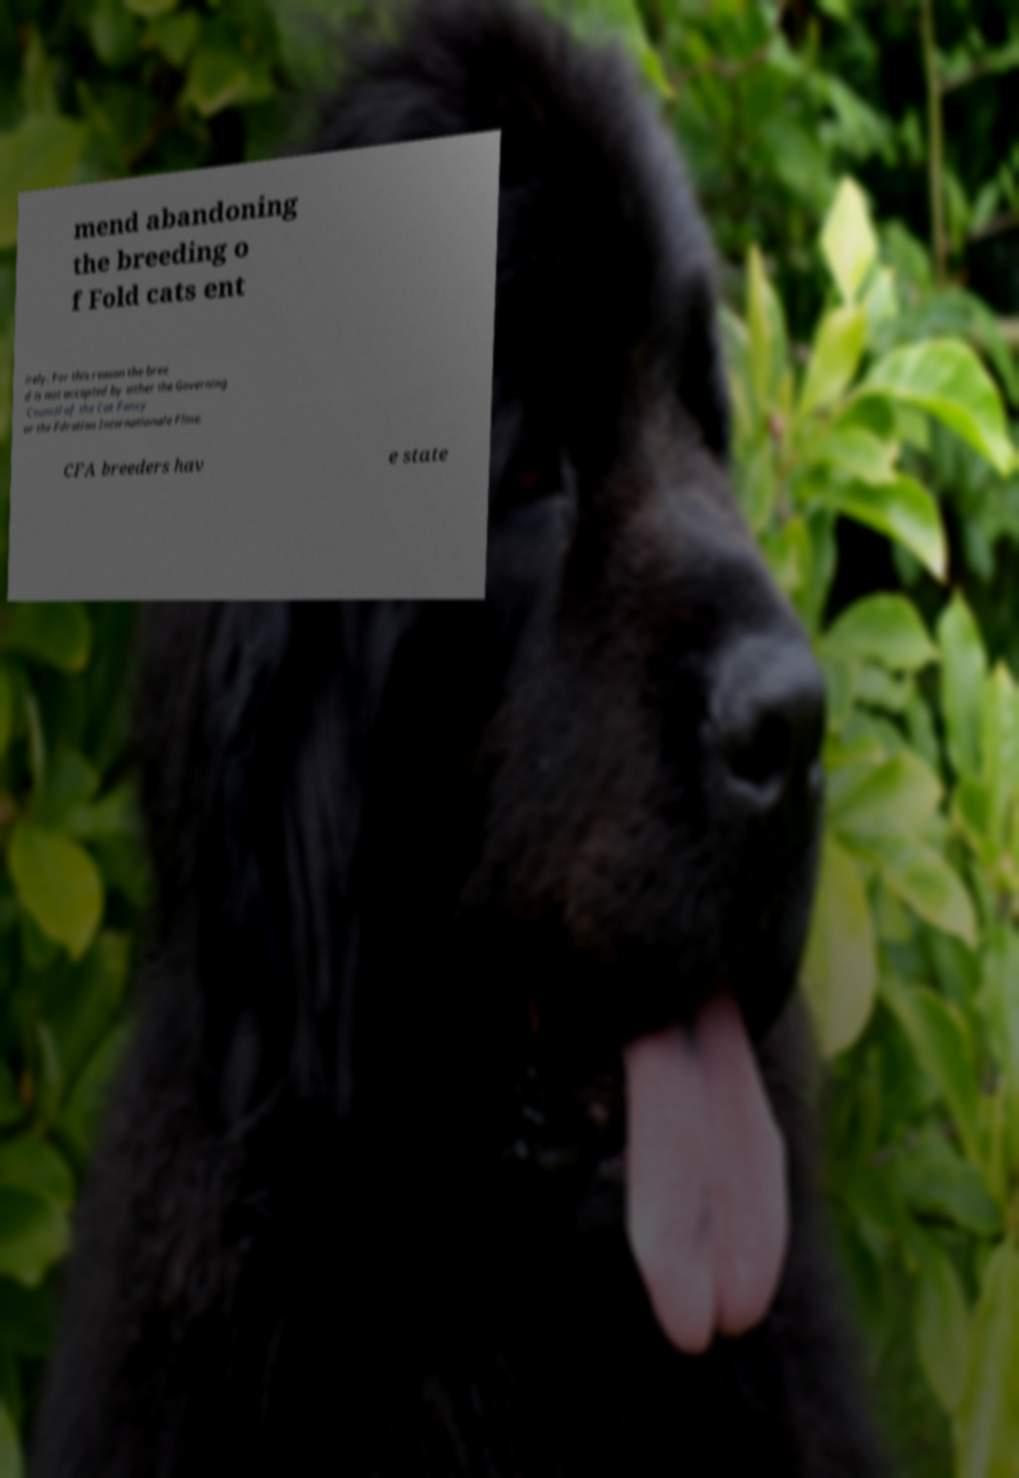For documentation purposes, I need the text within this image transcribed. Could you provide that? mend abandoning the breeding o f Fold cats ent irely. For this reason the bree d is not accepted by either the Governing Council of the Cat Fancy or the Fdration Internationale Fline. CFA breeders hav e state 